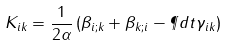<formula> <loc_0><loc_0><loc_500><loc_500>K _ { i k } = \frac { 1 } { 2 \alpha } \left ( \beta _ { i ; k } + \beta _ { k ; i } - \P d { t } \gamma _ { i k } \right )</formula> 